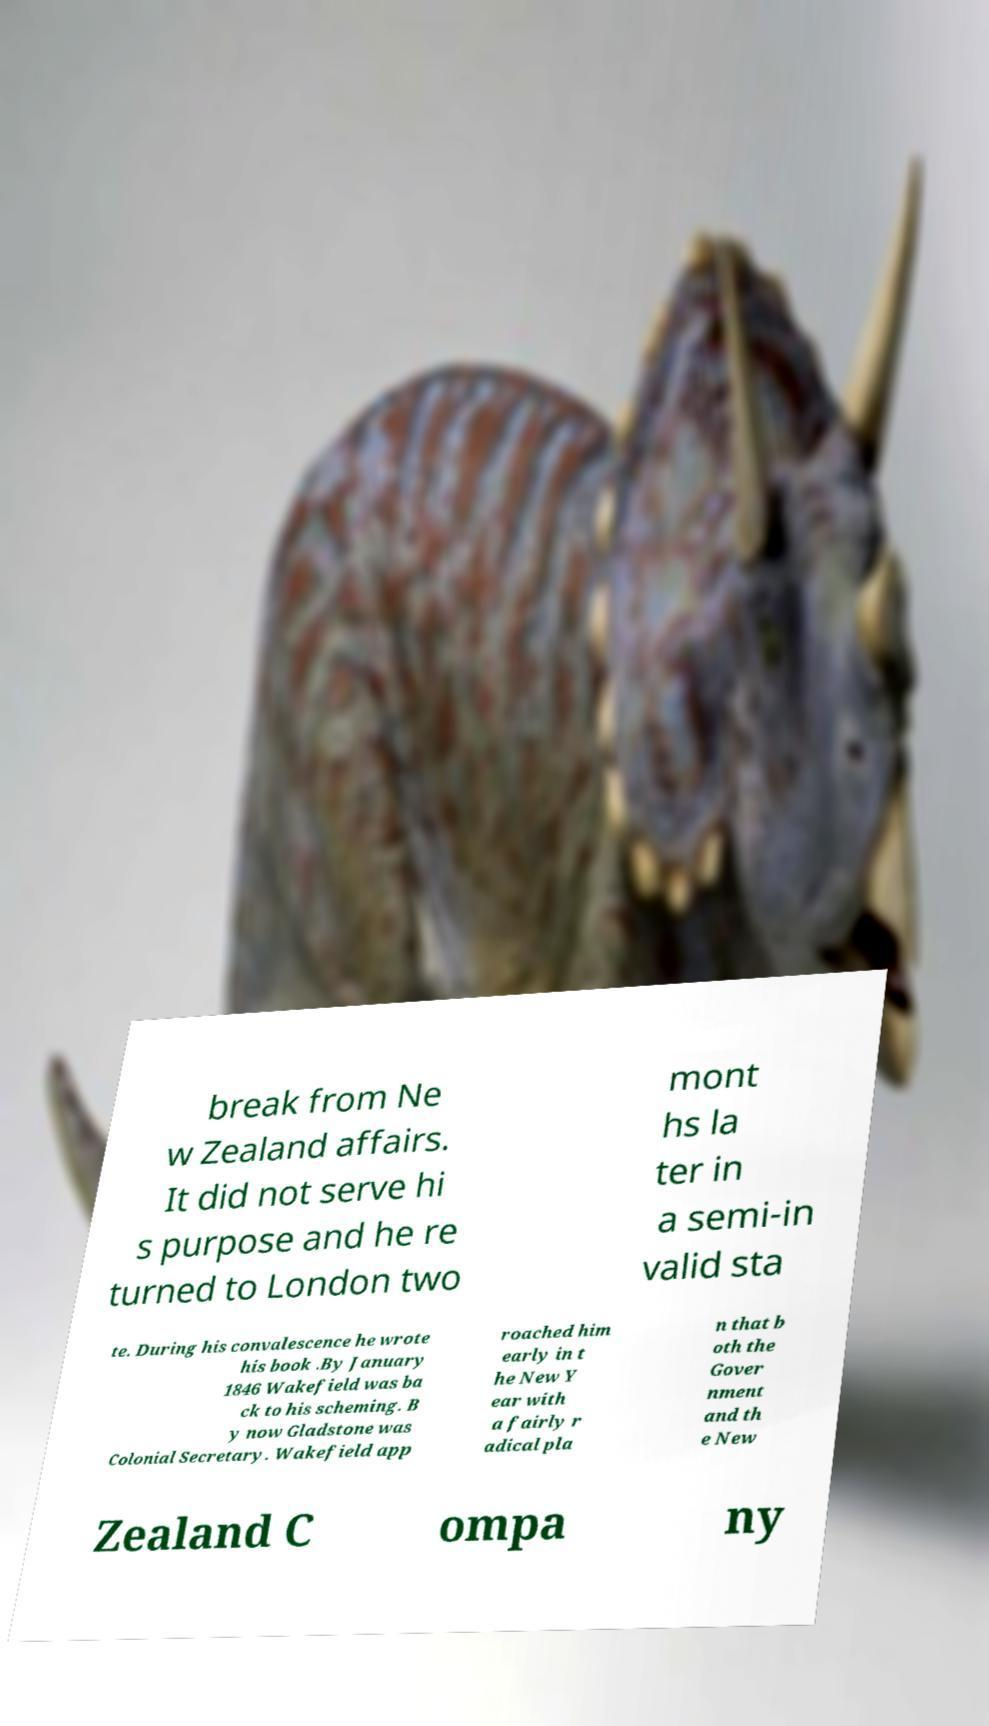What messages or text are displayed in this image? I need them in a readable, typed format. break from Ne w Zealand affairs. It did not serve hi s purpose and he re turned to London two mont hs la ter in a semi-in valid sta te. During his convalescence he wrote his book .By January 1846 Wakefield was ba ck to his scheming. B y now Gladstone was Colonial Secretary. Wakefield app roached him early in t he New Y ear with a fairly r adical pla n that b oth the Gover nment and th e New Zealand C ompa ny 